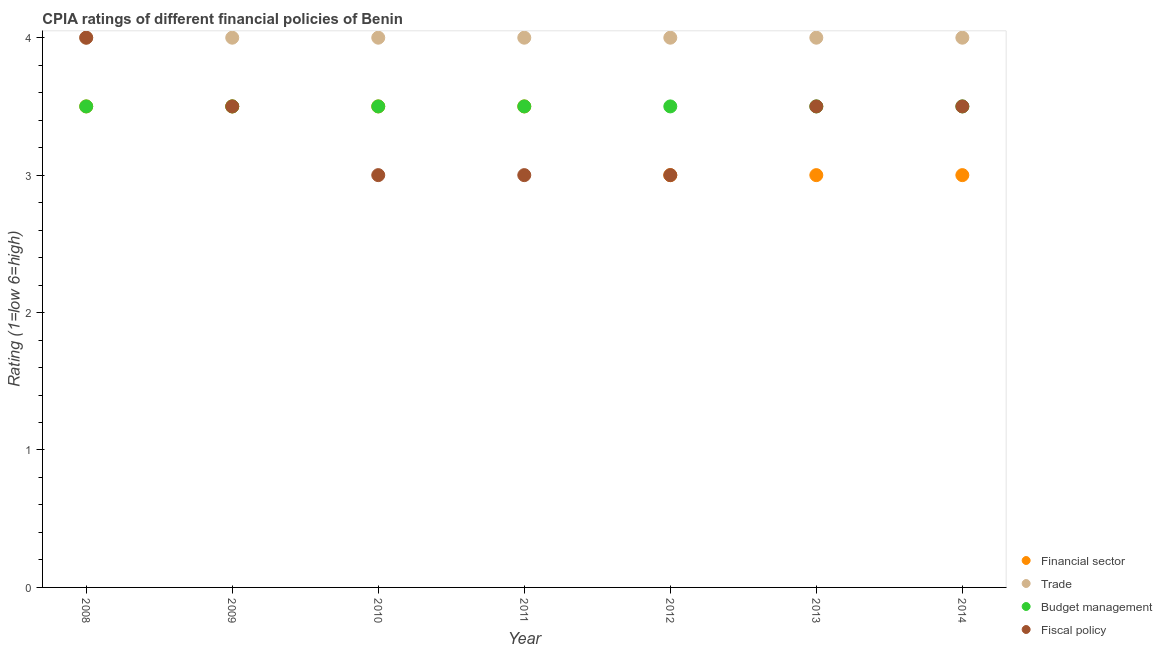Across all years, what is the maximum cpia rating of financial sector?
Make the answer very short. 3.5. Across all years, what is the minimum cpia rating of trade?
Keep it short and to the point. 4. In which year was the cpia rating of financial sector maximum?
Make the answer very short. 2008. What is the total cpia rating of budget management in the graph?
Your answer should be very brief. 24.5. What is the difference between the cpia rating of financial sector in 2011 and that in 2014?
Offer a terse response. 0.5. In how many years, is the cpia rating of budget management greater than 0.6000000000000001?
Make the answer very short. 7. Is the cpia rating of budget management in 2009 less than that in 2011?
Provide a succinct answer. No. In how many years, is the cpia rating of fiscal policy greater than the average cpia rating of fiscal policy taken over all years?
Offer a terse response. 4. Is the sum of the cpia rating of trade in 2010 and 2013 greater than the maximum cpia rating of budget management across all years?
Provide a short and direct response. Yes. Is it the case that in every year, the sum of the cpia rating of trade and cpia rating of budget management is greater than the sum of cpia rating of financial sector and cpia rating of fiscal policy?
Offer a very short reply. No. Is the cpia rating of budget management strictly greater than the cpia rating of financial sector over the years?
Your answer should be compact. No. How many dotlines are there?
Offer a very short reply. 4. How many years are there in the graph?
Your response must be concise. 7. What is the difference between two consecutive major ticks on the Y-axis?
Ensure brevity in your answer.  1. Are the values on the major ticks of Y-axis written in scientific E-notation?
Your answer should be compact. No. What is the title of the graph?
Give a very brief answer. CPIA ratings of different financial policies of Benin. What is the label or title of the X-axis?
Your answer should be very brief. Year. What is the Rating (1=low 6=high) of Trade in 2008?
Keep it short and to the point. 4. What is the Rating (1=low 6=high) of Budget management in 2008?
Your response must be concise. 3.5. What is the Rating (1=low 6=high) of Financial sector in 2009?
Ensure brevity in your answer.  3.5. What is the Rating (1=low 6=high) of Fiscal policy in 2009?
Keep it short and to the point. 3.5. What is the Rating (1=low 6=high) in Financial sector in 2010?
Provide a short and direct response. 3.5. What is the Rating (1=low 6=high) of Trade in 2010?
Provide a succinct answer. 4. What is the Rating (1=low 6=high) in Fiscal policy in 2010?
Ensure brevity in your answer.  3. What is the Rating (1=low 6=high) of Trade in 2011?
Your answer should be very brief. 4. What is the Rating (1=low 6=high) in Trade in 2012?
Your answer should be very brief. 4. What is the Rating (1=low 6=high) of Budget management in 2013?
Offer a terse response. 3.5. What is the Rating (1=low 6=high) of Financial sector in 2014?
Give a very brief answer. 3. What is the Rating (1=low 6=high) of Trade in 2014?
Keep it short and to the point. 4. What is the Rating (1=low 6=high) in Fiscal policy in 2014?
Provide a short and direct response. 3.5. Across all years, what is the maximum Rating (1=low 6=high) in Financial sector?
Keep it short and to the point. 3.5. Across all years, what is the maximum Rating (1=low 6=high) in Trade?
Your response must be concise. 4. Across all years, what is the minimum Rating (1=low 6=high) in Financial sector?
Offer a very short reply. 3. What is the total Rating (1=low 6=high) in Budget management in the graph?
Your response must be concise. 24.5. What is the total Rating (1=low 6=high) in Fiscal policy in the graph?
Your answer should be compact. 23.5. What is the difference between the Rating (1=low 6=high) in Budget management in 2008 and that in 2009?
Keep it short and to the point. 0. What is the difference between the Rating (1=low 6=high) in Financial sector in 2008 and that in 2010?
Offer a very short reply. 0. What is the difference between the Rating (1=low 6=high) of Trade in 2008 and that in 2010?
Offer a terse response. 0. What is the difference between the Rating (1=low 6=high) of Financial sector in 2008 and that in 2011?
Keep it short and to the point. 0. What is the difference between the Rating (1=low 6=high) in Budget management in 2008 and that in 2011?
Make the answer very short. 0. What is the difference between the Rating (1=low 6=high) of Financial sector in 2008 and that in 2012?
Provide a short and direct response. 0.5. What is the difference between the Rating (1=low 6=high) in Fiscal policy in 2008 and that in 2012?
Your response must be concise. 1. What is the difference between the Rating (1=low 6=high) of Financial sector in 2008 and that in 2014?
Your answer should be very brief. 0.5. What is the difference between the Rating (1=low 6=high) of Budget management in 2008 and that in 2014?
Provide a short and direct response. 0. What is the difference between the Rating (1=low 6=high) of Fiscal policy in 2008 and that in 2014?
Keep it short and to the point. 0.5. What is the difference between the Rating (1=low 6=high) in Fiscal policy in 2009 and that in 2010?
Keep it short and to the point. 0.5. What is the difference between the Rating (1=low 6=high) of Budget management in 2009 and that in 2011?
Give a very brief answer. 0. What is the difference between the Rating (1=low 6=high) of Fiscal policy in 2009 and that in 2011?
Your answer should be compact. 0.5. What is the difference between the Rating (1=low 6=high) of Financial sector in 2009 and that in 2012?
Give a very brief answer. 0.5. What is the difference between the Rating (1=low 6=high) in Trade in 2009 and that in 2012?
Offer a very short reply. 0. What is the difference between the Rating (1=low 6=high) in Budget management in 2009 and that in 2012?
Offer a terse response. 0. What is the difference between the Rating (1=low 6=high) of Fiscal policy in 2009 and that in 2013?
Make the answer very short. 0. What is the difference between the Rating (1=low 6=high) of Trade in 2009 and that in 2014?
Your answer should be very brief. 0. What is the difference between the Rating (1=low 6=high) of Budget management in 2009 and that in 2014?
Provide a succinct answer. 0. What is the difference between the Rating (1=low 6=high) in Trade in 2010 and that in 2011?
Provide a short and direct response. 0. What is the difference between the Rating (1=low 6=high) of Fiscal policy in 2010 and that in 2011?
Your response must be concise. 0. What is the difference between the Rating (1=low 6=high) in Financial sector in 2010 and that in 2012?
Keep it short and to the point. 0.5. What is the difference between the Rating (1=low 6=high) of Budget management in 2010 and that in 2012?
Your answer should be very brief. 0. What is the difference between the Rating (1=low 6=high) in Fiscal policy in 2010 and that in 2012?
Provide a short and direct response. 0. What is the difference between the Rating (1=low 6=high) in Budget management in 2010 and that in 2013?
Offer a very short reply. 0. What is the difference between the Rating (1=low 6=high) of Financial sector in 2010 and that in 2014?
Your answer should be very brief. 0.5. What is the difference between the Rating (1=low 6=high) in Budget management in 2010 and that in 2014?
Provide a short and direct response. 0. What is the difference between the Rating (1=low 6=high) in Trade in 2011 and that in 2012?
Keep it short and to the point. 0. What is the difference between the Rating (1=low 6=high) in Financial sector in 2011 and that in 2013?
Give a very brief answer. 0.5. What is the difference between the Rating (1=low 6=high) in Trade in 2011 and that in 2013?
Provide a short and direct response. 0. What is the difference between the Rating (1=low 6=high) in Fiscal policy in 2011 and that in 2013?
Keep it short and to the point. -0.5. What is the difference between the Rating (1=low 6=high) of Financial sector in 2011 and that in 2014?
Your response must be concise. 0.5. What is the difference between the Rating (1=low 6=high) of Budget management in 2011 and that in 2014?
Make the answer very short. 0. What is the difference between the Rating (1=low 6=high) of Financial sector in 2012 and that in 2013?
Your answer should be compact. 0. What is the difference between the Rating (1=low 6=high) of Trade in 2012 and that in 2013?
Your answer should be compact. 0. What is the difference between the Rating (1=low 6=high) in Fiscal policy in 2012 and that in 2013?
Ensure brevity in your answer.  -0.5. What is the difference between the Rating (1=low 6=high) in Financial sector in 2012 and that in 2014?
Give a very brief answer. 0. What is the difference between the Rating (1=low 6=high) in Trade in 2012 and that in 2014?
Offer a terse response. 0. What is the difference between the Rating (1=low 6=high) in Financial sector in 2013 and that in 2014?
Your response must be concise. 0. What is the difference between the Rating (1=low 6=high) in Budget management in 2013 and that in 2014?
Offer a very short reply. 0. What is the difference between the Rating (1=low 6=high) in Financial sector in 2008 and the Rating (1=low 6=high) in Trade in 2009?
Provide a succinct answer. -0.5. What is the difference between the Rating (1=low 6=high) in Financial sector in 2008 and the Rating (1=low 6=high) in Budget management in 2009?
Your answer should be compact. 0. What is the difference between the Rating (1=low 6=high) in Financial sector in 2008 and the Rating (1=low 6=high) in Fiscal policy in 2009?
Offer a terse response. 0. What is the difference between the Rating (1=low 6=high) of Trade in 2008 and the Rating (1=low 6=high) of Budget management in 2009?
Make the answer very short. 0.5. What is the difference between the Rating (1=low 6=high) in Trade in 2008 and the Rating (1=low 6=high) in Fiscal policy in 2009?
Offer a terse response. 0.5. What is the difference between the Rating (1=low 6=high) of Financial sector in 2008 and the Rating (1=low 6=high) of Trade in 2010?
Provide a succinct answer. -0.5. What is the difference between the Rating (1=low 6=high) of Financial sector in 2008 and the Rating (1=low 6=high) of Budget management in 2010?
Provide a succinct answer. 0. What is the difference between the Rating (1=low 6=high) of Financial sector in 2008 and the Rating (1=low 6=high) of Fiscal policy in 2010?
Ensure brevity in your answer.  0.5. What is the difference between the Rating (1=low 6=high) in Budget management in 2008 and the Rating (1=low 6=high) in Fiscal policy in 2010?
Make the answer very short. 0.5. What is the difference between the Rating (1=low 6=high) in Budget management in 2008 and the Rating (1=low 6=high) in Fiscal policy in 2011?
Provide a succinct answer. 0.5. What is the difference between the Rating (1=low 6=high) of Financial sector in 2008 and the Rating (1=low 6=high) of Trade in 2012?
Your answer should be compact. -0.5. What is the difference between the Rating (1=low 6=high) of Financial sector in 2008 and the Rating (1=low 6=high) of Budget management in 2012?
Offer a terse response. 0. What is the difference between the Rating (1=low 6=high) in Trade in 2008 and the Rating (1=low 6=high) in Budget management in 2012?
Make the answer very short. 0.5. What is the difference between the Rating (1=low 6=high) in Financial sector in 2008 and the Rating (1=low 6=high) in Budget management in 2013?
Keep it short and to the point. 0. What is the difference between the Rating (1=low 6=high) in Financial sector in 2008 and the Rating (1=low 6=high) in Fiscal policy in 2013?
Your response must be concise. 0. What is the difference between the Rating (1=low 6=high) of Trade in 2008 and the Rating (1=low 6=high) of Budget management in 2013?
Ensure brevity in your answer.  0.5. What is the difference between the Rating (1=low 6=high) of Trade in 2008 and the Rating (1=low 6=high) of Fiscal policy in 2013?
Offer a terse response. 0.5. What is the difference between the Rating (1=low 6=high) in Budget management in 2008 and the Rating (1=low 6=high) in Fiscal policy in 2013?
Keep it short and to the point. 0. What is the difference between the Rating (1=low 6=high) of Financial sector in 2008 and the Rating (1=low 6=high) of Trade in 2014?
Your answer should be very brief. -0.5. What is the difference between the Rating (1=low 6=high) of Financial sector in 2008 and the Rating (1=low 6=high) of Budget management in 2014?
Your response must be concise. 0. What is the difference between the Rating (1=low 6=high) in Financial sector in 2008 and the Rating (1=low 6=high) in Fiscal policy in 2014?
Ensure brevity in your answer.  0. What is the difference between the Rating (1=low 6=high) in Trade in 2008 and the Rating (1=low 6=high) in Budget management in 2014?
Offer a terse response. 0.5. What is the difference between the Rating (1=low 6=high) in Trade in 2008 and the Rating (1=low 6=high) in Fiscal policy in 2014?
Your response must be concise. 0.5. What is the difference between the Rating (1=low 6=high) of Financial sector in 2009 and the Rating (1=low 6=high) of Budget management in 2010?
Provide a succinct answer. 0. What is the difference between the Rating (1=low 6=high) in Financial sector in 2009 and the Rating (1=low 6=high) in Fiscal policy in 2010?
Offer a terse response. 0.5. What is the difference between the Rating (1=low 6=high) of Trade in 2009 and the Rating (1=low 6=high) of Fiscal policy in 2010?
Keep it short and to the point. 1. What is the difference between the Rating (1=low 6=high) of Financial sector in 2009 and the Rating (1=low 6=high) of Fiscal policy in 2011?
Your answer should be compact. 0.5. What is the difference between the Rating (1=low 6=high) in Trade in 2009 and the Rating (1=low 6=high) in Budget management in 2011?
Your answer should be compact. 0.5. What is the difference between the Rating (1=low 6=high) in Budget management in 2009 and the Rating (1=low 6=high) in Fiscal policy in 2011?
Provide a succinct answer. 0.5. What is the difference between the Rating (1=low 6=high) of Financial sector in 2009 and the Rating (1=low 6=high) of Trade in 2012?
Offer a terse response. -0.5. What is the difference between the Rating (1=low 6=high) of Financial sector in 2009 and the Rating (1=low 6=high) of Fiscal policy in 2012?
Your response must be concise. 0.5. What is the difference between the Rating (1=low 6=high) in Financial sector in 2009 and the Rating (1=low 6=high) in Trade in 2014?
Your answer should be compact. -0.5. What is the difference between the Rating (1=low 6=high) in Financial sector in 2009 and the Rating (1=low 6=high) in Budget management in 2014?
Give a very brief answer. 0. What is the difference between the Rating (1=low 6=high) in Trade in 2010 and the Rating (1=low 6=high) in Budget management in 2011?
Provide a short and direct response. 0.5. What is the difference between the Rating (1=low 6=high) in Trade in 2010 and the Rating (1=low 6=high) in Fiscal policy in 2011?
Offer a very short reply. 1. What is the difference between the Rating (1=low 6=high) of Budget management in 2010 and the Rating (1=low 6=high) of Fiscal policy in 2011?
Ensure brevity in your answer.  0.5. What is the difference between the Rating (1=low 6=high) in Financial sector in 2010 and the Rating (1=low 6=high) in Trade in 2012?
Your answer should be compact. -0.5. What is the difference between the Rating (1=low 6=high) of Trade in 2010 and the Rating (1=low 6=high) of Budget management in 2012?
Ensure brevity in your answer.  0.5. What is the difference between the Rating (1=low 6=high) in Trade in 2010 and the Rating (1=low 6=high) in Fiscal policy in 2012?
Make the answer very short. 1. What is the difference between the Rating (1=low 6=high) in Financial sector in 2010 and the Rating (1=low 6=high) in Budget management in 2013?
Offer a terse response. 0. What is the difference between the Rating (1=low 6=high) in Financial sector in 2010 and the Rating (1=low 6=high) in Fiscal policy in 2013?
Offer a terse response. 0. What is the difference between the Rating (1=low 6=high) of Budget management in 2010 and the Rating (1=low 6=high) of Fiscal policy in 2013?
Your response must be concise. 0. What is the difference between the Rating (1=low 6=high) in Financial sector in 2010 and the Rating (1=low 6=high) in Trade in 2014?
Your answer should be compact. -0.5. What is the difference between the Rating (1=low 6=high) in Trade in 2010 and the Rating (1=low 6=high) in Budget management in 2014?
Your answer should be compact. 0.5. What is the difference between the Rating (1=low 6=high) in Financial sector in 2011 and the Rating (1=low 6=high) in Fiscal policy in 2012?
Your answer should be very brief. 0.5. What is the difference between the Rating (1=low 6=high) in Trade in 2011 and the Rating (1=low 6=high) in Fiscal policy in 2012?
Your response must be concise. 1. What is the difference between the Rating (1=low 6=high) of Budget management in 2011 and the Rating (1=low 6=high) of Fiscal policy in 2012?
Provide a succinct answer. 0.5. What is the difference between the Rating (1=low 6=high) in Financial sector in 2011 and the Rating (1=low 6=high) in Trade in 2013?
Provide a succinct answer. -0.5. What is the difference between the Rating (1=low 6=high) in Financial sector in 2011 and the Rating (1=low 6=high) in Fiscal policy in 2013?
Offer a terse response. 0. What is the difference between the Rating (1=low 6=high) of Trade in 2011 and the Rating (1=low 6=high) of Fiscal policy in 2013?
Ensure brevity in your answer.  0.5. What is the difference between the Rating (1=low 6=high) of Budget management in 2011 and the Rating (1=low 6=high) of Fiscal policy in 2013?
Make the answer very short. 0. What is the difference between the Rating (1=low 6=high) of Financial sector in 2011 and the Rating (1=low 6=high) of Fiscal policy in 2014?
Provide a short and direct response. 0. What is the difference between the Rating (1=low 6=high) of Trade in 2011 and the Rating (1=low 6=high) of Budget management in 2014?
Your answer should be compact. 0.5. What is the difference between the Rating (1=low 6=high) in Budget management in 2011 and the Rating (1=low 6=high) in Fiscal policy in 2014?
Your answer should be very brief. 0. What is the difference between the Rating (1=low 6=high) of Financial sector in 2012 and the Rating (1=low 6=high) of Fiscal policy in 2013?
Ensure brevity in your answer.  -0.5. What is the difference between the Rating (1=low 6=high) in Budget management in 2012 and the Rating (1=low 6=high) in Fiscal policy in 2013?
Keep it short and to the point. 0. What is the difference between the Rating (1=low 6=high) in Financial sector in 2012 and the Rating (1=low 6=high) in Budget management in 2014?
Offer a terse response. -0.5. What is the difference between the Rating (1=low 6=high) in Financial sector in 2012 and the Rating (1=low 6=high) in Fiscal policy in 2014?
Your response must be concise. -0.5. What is the difference between the Rating (1=low 6=high) in Trade in 2012 and the Rating (1=low 6=high) in Budget management in 2014?
Keep it short and to the point. 0.5. What is the difference between the Rating (1=low 6=high) in Trade in 2012 and the Rating (1=low 6=high) in Fiscal policy in 2014?
Offer a terse response. 0.5. What is the difference between the Rating (1=low 6=high) of Financial sector in 2013 and the Rating (1=low 6=high) of Budget management in 2014?
Keep it short and to the point. -0.5. What is the difference between the Rating (1=low 6=high) in Trade in 2013 and the Rating (1=low 6=high) in Fiscal policy in 2014?
Provide a short and direct response. 0.5. What is the average Rating (1=low 6=high) of Financial sector per year?
Your answer should be very brief. 3.29. What is the average Rating (1=low 6=high) of Fiscal policy per year?
Give a very brief answer. 3.36. In the year 2008, what is the difference between the Rating (1=low 6=high) in Financial sector and Rating (1=low 6=high) in Trade?
Provide a short and direct response. -0.5. In the year 2008, what is the difference between the Rating (1=low 6=high) in Financial sector and Rating (1=low 6=high) in Fiscal policy?
Your response must be concise. -0.5. In the year 2009, what is the difference between the Rating (1=low 6=high) in Financial sector and Rating (1=low 6=high) in Budget management?
Keep it short and to the point. 0. In the year 2009, what is the difference between the Rating (1=low 6=high) in Financial sector and Rating (1=low 6=high) in Fiscal policy?
Give a very brief answer. 0. In the year 2010, what is the difference between the Rating (1=low 6=high) in Financial sector and Rating (1=low 6=high) in Budget management?
Your response must be concise. 0. In the year 2010, what is the difference between the Rating (1=low 6=high) in Trade and Rating (1=low 6=high) in Budget management?
Your response must be concise. 0.5. In the year 2010, what is the difference between the Rating (1=low 6=high) in Budget management and Rating (1=low 6=high) in Fiscal policy?
Keep it short and to the point. 0.5. In the year 2011, what is the difference between the Rating (1=low 6=high) in Trade and Rating (1=low 6=high) in Budget management?
Your answer should be compact. 0.5. In the year 2011, what is the difference between the Rating (1=low 6=high) in Trade and Rating (1=low 6=high) in Fiscal policy?
Your response must be concise. 1. In the year 2012, what is the difference between the Rating (1=low 6=high) of Trade and Rating (1=low 6=high) of Fiscal policy?
Offer a very short reply. 1. In the year 2013, what is the difference between the Rating (1=low 6=high) in Financial sector and Rating (1=low 6=high) in Trade?
Provide a short and direct response. -1. In the year 2013, what is the difference between the Rating (1=low 6=high) of Financial sector and Rating (1=low 6=high) of Fiscal policy?
Give a very brief answer. -0.5. In the year 2013, what is the difference between the Rating (1=low 6=high) of Trade and Rating (1=low 6=high) of Budget management?
Provide a succinct answer. 0.5. In the year 2013, what is the difference between the Rating (1=low 6=high) of Trade and Rating (1=low 6=high) of Fiscal policy?
Provide a succinct answer. 0.5. In the year 2013, what is the difference between the Rating (1=low 6=high) of Budget management and Rating (1=low 6=high) of Fiscal policy?
Provide a short and direct response. 0. In the year 2014, what is the difference between the Rating (1=low 6=high) in Financial sector and Rating (1=low 6=high) in Trade?
Your answer should be very brief. -1. In the year 2014, what is the difference between the Rating (1=low 6=high) in Trade and Rating (1=low 6=high) in Budget management?
Your response must be concise. 0.5. In the year 2014, what is the difference between the Rating (1=low 6=high) in Budget management and Rating (1=low 6=high) in Fiscal policy?
Your response must be concise. 0. What is the ratio of the Rating (1=low 6=high) of Financial sector in 2008 to that in 2009?
Offer a very short reply. 1. What is the ratio of the Rating (1=low 6=high) of Fiscal policy in 2008 to that in 2009?
Your response must be concise. 1.14. What is the ratio of the Rating (1=low 6=high) of Fiscal policy in 2008 to that in 2010?
Ensure brevity in your answer.  1.33. What is the ratio of the Rating (1=low 6=high) in Budget management in 2008 to that in 2011?
Provide a short and direct response. 1. What is the ratio of the Rating (1=low 6=high) of Fiscal policy in 2008 to that in 2011?
Provide a short and direct response. 1.33. What is the ratio of the Rating (1=low 6=high) in Financial sector in 2008 to that in 2012?
Offer a terse response. 1.17. What is the ratio of the Rating (1=low 6=high) of Trade in 2008 to that in 2012?
Make the answer very short. 1. What is the ratio of the Rating (1=low 6=high) in Financial sector in 2008 to that in 2013?
Keep it short and to the point. 1.17. What is the ratio of the Rating (1=low 6=high) in Trade in 2008 to that in 2013?
Your answer should be very brief. 1. What is the ratio of the Rating (1=low 6=high) of Financial sector in 2008 to that in 2014?
Offer a terse response. 1.17. What is the ratio of the Rating (1=low 6=high) of Trade in 2008 to that in 2014?
Your answer should be compact. 1. What is the ratio of the Rating (1=low 6=high) of Budget management in 2008 to that in 2014?
Your answer should be compact. 1. What is the ratio of the Rating (1=low 6=high) of Trade in 2009 to that in 2010?
Provide a succinct answer. 1. What is the ratio of the Rating (1=low 6=high) in Budget management in 2009 to that in 2010?
Your answer should be very brief. 1. What is the ratio of the Rating (1=low 6=high) in Fiscal policy in 2009 to that in 2010?
Offer a very short reply. 1.17. What is the ratio of the Rating (1=low 6=high) of Financial sector in 2009 to that in 2011?
Give a very brief answer. 1. What is the ratio of the Rating (1=low 6=high) of Trade in 2009 to that in 2011?
Your response must be concise. 1. What is the ratio of the Rating (1=low 6=high) of Budget management in 2009 to that in 2011?
Your response must be concise. 1. What is the ratio of the Rating (1=low 6=high) in Fiscal policy in 2009 to that in 2011?
Your answer should be very brief. 1.17. What is the ratio of the Rating (1=low 6=high) of Financial sector in 2009 to that in 2012?
Keep it short and to the point. 1.17. What is the ratio of the Rating (1=low 6=high) of Fiscal policy in 2009 to that in 2012?
Your answer should be compact. 1.17. What is the ratio of the Rating (1=low 6=high) in Financial sector in 2009 to that in 2013?
Offer a terse response. 1.17. What is the ratio of the Rating (1=low 6=high) of Fiscal policy in 2009 to that in 2013?
Offer a very short reply. 1. What is the ratio of the Rating (1=low 6=high) of Financial sector in 2009 to that in 2014?
Your answer should be very brief. 1.17. What is the ratio of the Rating (1=low 6=high) of Trade in 2009 to that in 2014?
Offer a very short reply. 1. What is the ratio of the Rating (1=low 6=high) of Fiscal policy in 2009 to that in 2014?
Provide a short and direct response. 1. What is the ratio of the Rating (1=low 6=high) in Financial sector in 2010 to that in 2011?
Give a very brief answer. 1. What is the ratio of the Rating (1=low 6=high) in Trade in 2010 to that in 2011?
Offer a very short reply. 1. What is the ratio of the Rating (1=low 6=high) of Budget management in 2010 to that in 2011?
Keep it short and to the point. 1. What is the ratio of the Rating (1=low 6=high) in Fiscal policy in 2010 to that in 2011?
Offer a very short reply. 1. What is the ratio of the Rating (1=low 6=high) in Budget management in 2010 to that in 2012?
Provide a succinct answer. 1. What is the ratio of the Rating (1=low 6=high) in Trade in 2010 to that in 2013?
Your answer should be compact. 1. What is the ratio of the Rating (1=low 6=high) in Budget management in 2010 to that in 2013?
Give a very brief answer. 1. What is the ratio of the Rating (1=low 6=high) of Financial sector in 2010 to that in 2014?
Offer a very short reply. 1.17. What is the ratio of the Rating (1=low 6=high) in Trade in 2010 to that in 2014?
Offer a very short reply. 1. What is the ratio of the Rating (1=low 6=high) in Fiscal policy in 2011 to that in 2012?
Your answer should be compact. 1. What is the ratio of the Rating (1=low 6=high) of Trade in 2011 to that in 2013?
Provide a short and direct response. 1. What is the ratio of the Rating (1=low 6=high) of Fiscal policy in 2011 to that in 2013?
Your answer should be very brief. 0.86. What is the ratio of the Rating (1=low 6=high) of Financial sector in 2011 to that in 2014?
Provide a succinct answer. 1.17. What is the ratio of the Rating (1=low 6=high) of Trade in 2011 to that in 2014?
Offer a terse response. 1. What is the ratio of the Rating (1=low 6=high) of Budget management in 2011 to that in 2014?
Your answer should be compact. 1. What is the ratio of the Rating (1=low 6=high) of Fiscal policy in 2011 to that in 2014?
Ensure brevity in your answer.  0.86. What is the ratio of the Rating (1=low 6=high) of Financial sector in 2012 to that in 2013?
Your answer should be very brief. 1. What is the ratio of the Rating (1=low 6=high) in Trade in 2012 to that in 2013?
Offer a very short reply. 1. What is the ratio of the Rating (1=low 6=high) of Fiscal policy in 2012 to that in 2013?
Provide a short and direct response. 0.86. What is the ratio of the Rating (1=low 6=high) of Financial sector in 2012 to that in 2014?
Keep it short and to the point. 1. What is the ratio of the Rating (1=low 6=high) in Fiscal policy in 2012 to that in 2014?
Your response must be concise. 0.86. What is the ratio of the Rating (1=low 6=high) in Financial sector in 2013 to that in 2014?
Your answer should be very brief. 1. What is the ratio of the Rating (1=low 6=high) in Trade in 2013 to that in 2014?
Offer a very short reply. 1. What is the ratio of the Rating (1=low 6=high) of Budget management in 2013 to that in 2014?
Make the answer very short. 1. What is the ratio of the Rating (1=low 6=high) of Fiscal policy in 2013 to that in 2014?
Offer a very short reply. 1. What is the difference between the highest and the second highest Rating (1=low 6=high) in Financial sector?
Ensure brevity in your answer.  0. What is the difference between the highest and the second highest Rating (1=low 6=high) in Trade?
Offer a very short reply. 0. What is the difference between the highest and the second highest Rating (1=low 6=high) of Budget management?
Your response must be concise. 0. What is the difference between the highest and the lowest Rating (1=low 6=high) in Trade?
Make the answer very short. 0. 